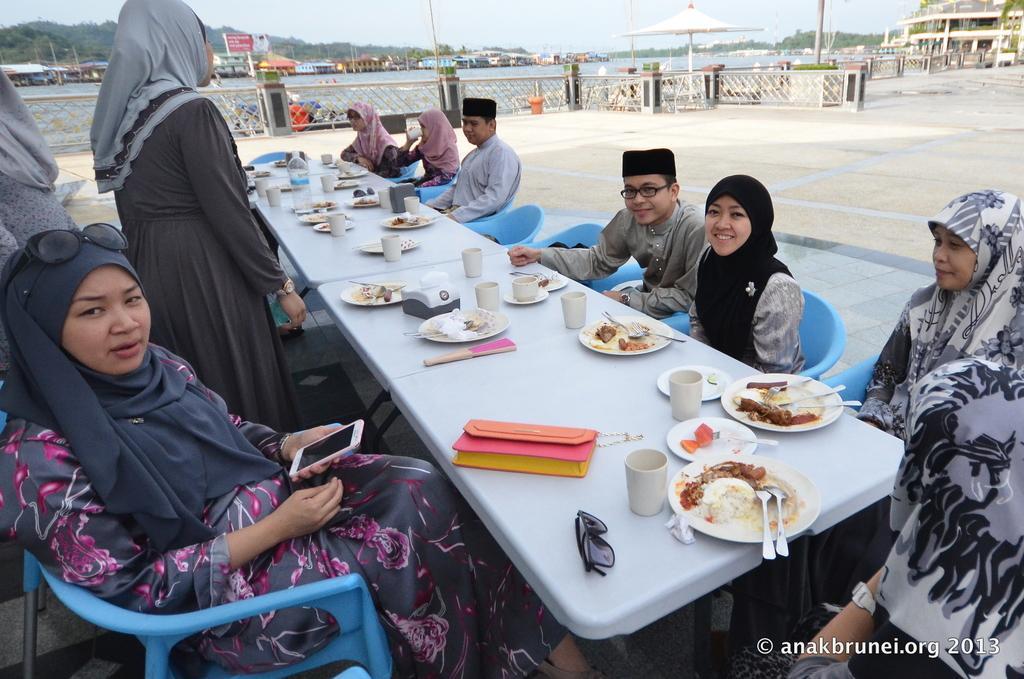Please provide a concise description of this image. In this picture there are many people sitting on a blue color chair. In front of them there is a table. On the table there is a wallet, cup, plate, spoon, tissue, water bottle and glasses. And a lady to the left side is standing. In the background there are some building, fencing, water and hills. 